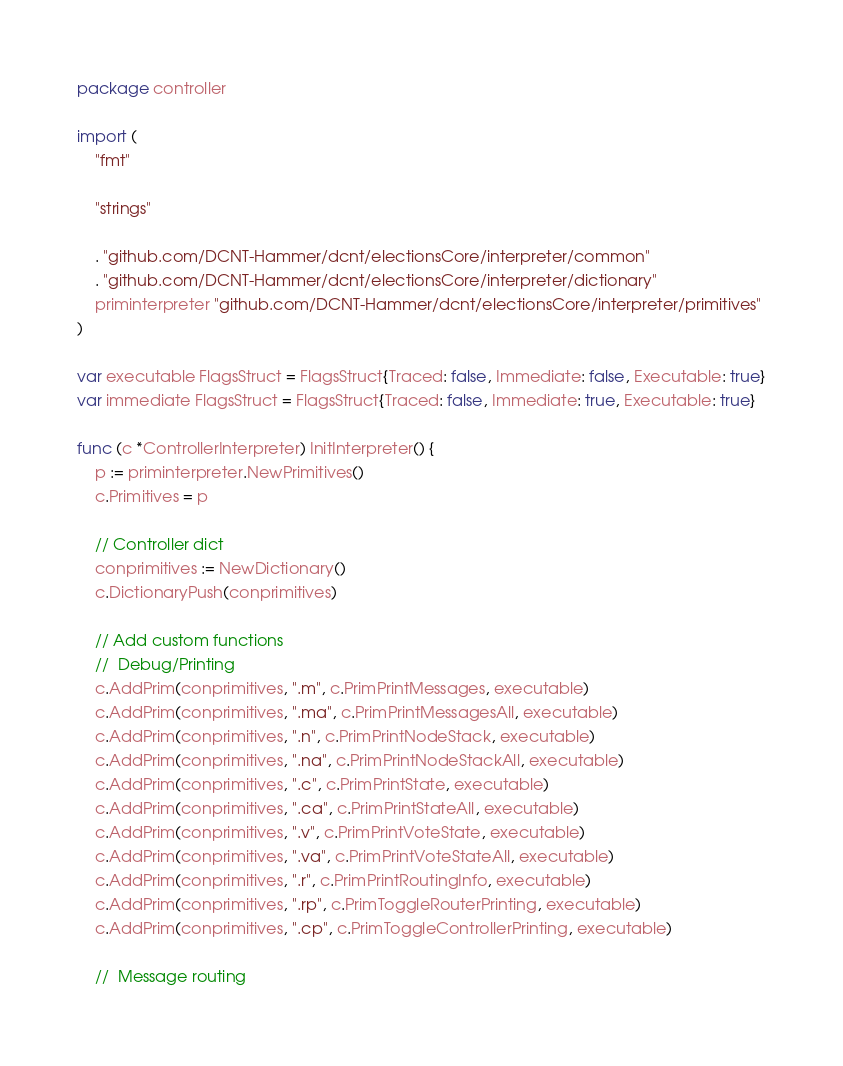<code> <loc_0><loc_0><loc_500><loc_500><_Go_>package controller

import (
	"fmt"

	"strings"

	. "github.com/DCNT-Hammer/dcnt/electionsCore/interpreter/common"
	. "github.com/DCNT-Hammer/dcnt/electionsCore/interpreter/dictionary"
	priminterpreter "github.com/DCNT-Hammer/dcnt/electionsCore/interpreter/primitives"
)

var executable FlagsStruct = FlagsStruct{Traced: false, Immediate: false, Executable: true}
var immediate FlagsStruct = FlagsStruct{Traced: false, Immediate: true, Executable: true}

func (c *ControllerInterpreter) InitInterpreter() {
	p := priminterpreter.NewPrimitives()
	c.Primitives = p

	// Controller dict
	conprimitives := NewDictionary()
	c.DictionaryPush(conprimitives)

	// Add custom functions
	//	Debug/Printing
	c.AddPrim(conprimitives, ".m", c.PrimPrintMessages, executable)
	c.AddPrim(conprimitives, ".ma", c.PrimPrintMessagesAll, executable)
	c.AddPrim(conprimitives, ".n", c.PrimPrintNodeStack, executable)
	c.AddPrim(conprimitives, ".na", c.PrimPrintNodeStackAll, executable)
	c.AddPrim(conprimitives, ".c", c.PrimPrintState, executable)
	c.AddPrim(conprimitives, ".ca", c.PrimPrintStateAll, executable)
	c.AddPrim(conprimitives, ".v", c.PrimPrintVoteState, executable)
	c.AddPrim(conprimitives, ".va", c.PrimPrintVoteStateAll, executable)
	c.AddPrim(conprimitives, ".r", c.PrimPrintRoutingInfo, executable)
	c.AddPrim(conprimitives, ".rp", c.PrimToggleRouterPrinting, executable)
	c.AddPrim(conprimitives, ".cp", c.PrimToggleControllerPrinting, executable)

	//	Message routing</code> 